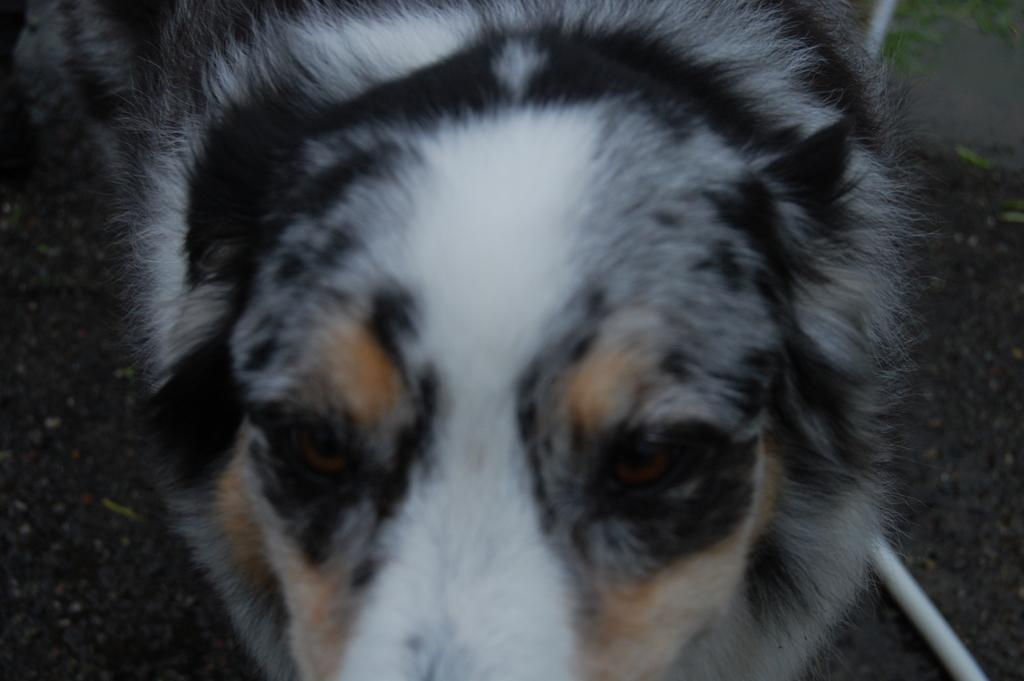What type of animal can be seen in the image? There is an animal with white and black fur in the image. Can you describe the appearance of the animal? The animal has white and black fur. What else is visible on the floor at the right bottom of the image? There is a white pipe on the floor at the right bottom of the image. What time of day is the destruction taking place in the image? There is no destruction present in the image, so it is not possible to determine the time of day. 